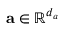Convert formula to latex. <formula><loc_0><loc_0><loc_500><loc_500>a \in \mathbb { R } ^ { d _ { a } }</formula> 